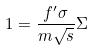<formula> <loc_0><loc_0><loc_500><loc_500>1 = \frac { f ^ { \prime } \sigma } { m \sqrt { s } } \Sigma</formula> 